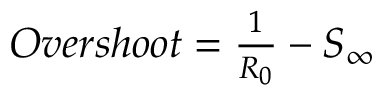<formula> <loc_0><loc_0><loc_500><loc_500>\begin{array} { r } { O v e r s h o o t = \frac { 1 } { R _ { 0 } } - S _ { \infty } } \end{array}</formula> 